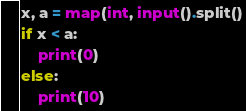Convert code to text. <code><loc_0><loc_0><loc_500><loc_500><_Python_>x, a = map(int, input().split()
if x < a:
    print(0)
else:
    print(10)</code> 